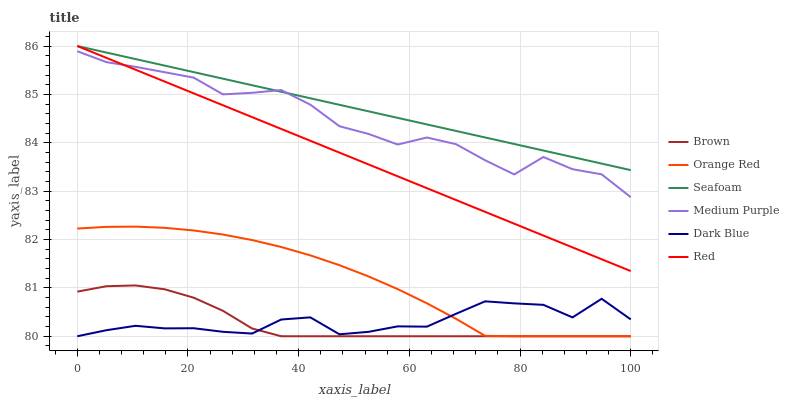Does Brown have the minimum area under the curve?
Answer yes or no. Yes. Does Seafoam have the maximum area under the curve?
Answer yes or no. Yes. Does Medium Purple have the minimum area under the curve?
Answer yes or no. No. Does Medium Purple have the maximum area under the curve?
Answer yes or no. No. Is Seafoam the smoothest?
Answer yes or no. Yes. Is Medium Purple the roughest?
Answer yes or no. Yes. Is Medium Purple the smoothest?
Answer yes or no. No. Is Seafoam the roughest?
Answer yes or no. No. Does Brown have the lowest value?
Answer yes or no. Yes. Does Medium Purple have the lowest value?
Answer yes or no. No. Does Red have the highest value?
Answer yes or no. Yes. Does Medium Purple have the highest value?
Answer yes or no. No. Is Brown less than Medium Purple?
Answer yes or no. Yes. Is Seafoam greater than Orange Red?
Answer yes or no. Yes. Does Dark Blue intersect Orange Red?
Answer yes or no. Yes. Is Dark Blue less than Orange Red?
Answer yes or no. No. Is Dark Blue greater than Orange Red?
Answer yes or no. No. Does Brown intersect Medium Purple?
Answer yes or no. No. 